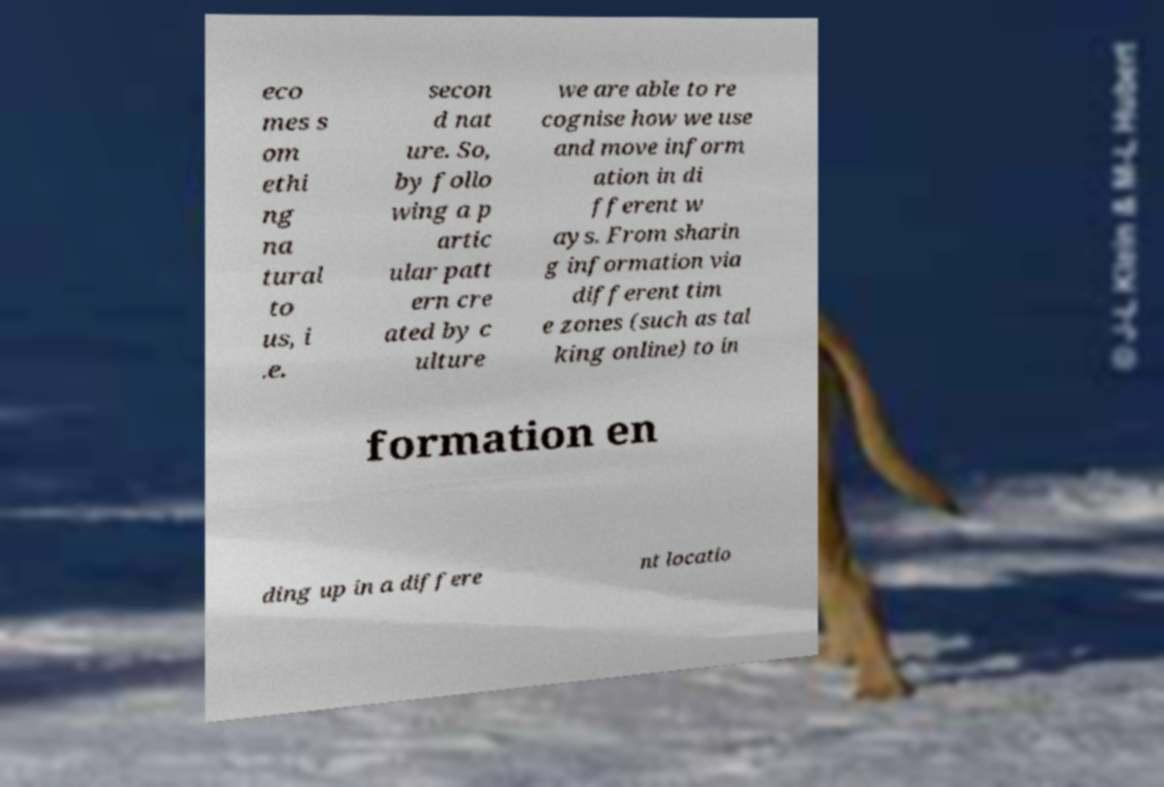For documentation purposes, I need the text within this image transcribed. Could you provide that? eco mes s om ethi ng na tural to us, i .e. secon d nat ure. So, by follo wing a p artic ular patt ern cre ated by c ulture we are able to re cognise how we use and move inform ation in di fferent w ays. From sharin g information via different tim e zones (such as tal king online) to in formation en ding up in a differe nt locatio 